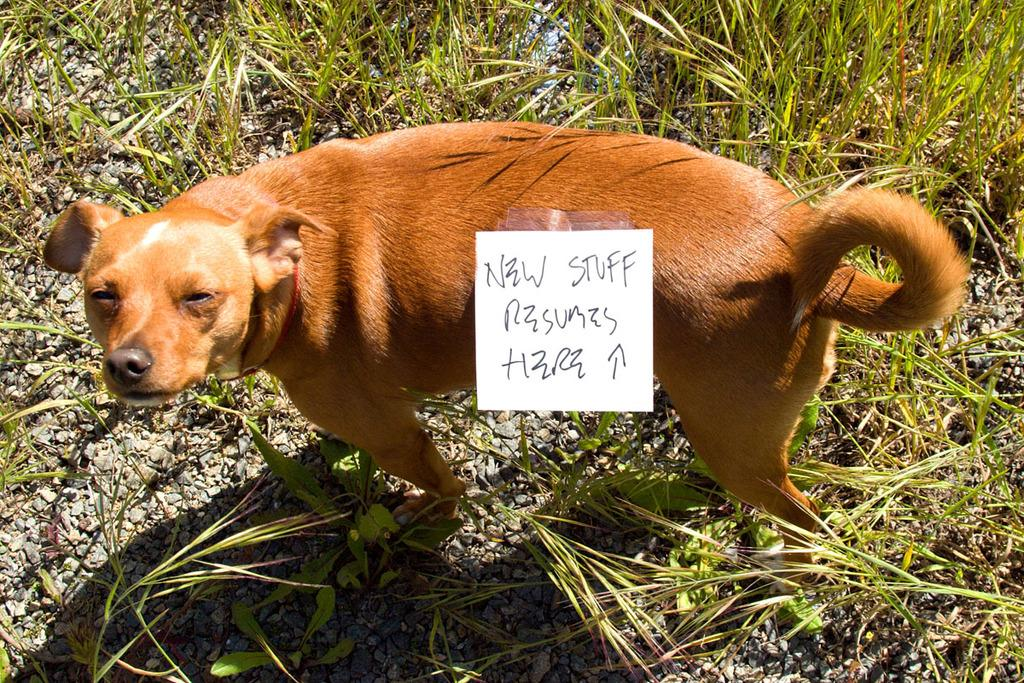What is the main subject in the center of the image? There is a dog in the center of the image. What else is in the center of the image besides the dog? There is a board in the center of the image. What type of natural environment is visible in the background of the image? There is grass visible in the background of the image. What other elements can be seen in the background of the image? There are stones present in the background of the image. What type of wax can be seen melting on the dog in the image? There is no wax present in the image, and the dog is not melting. 